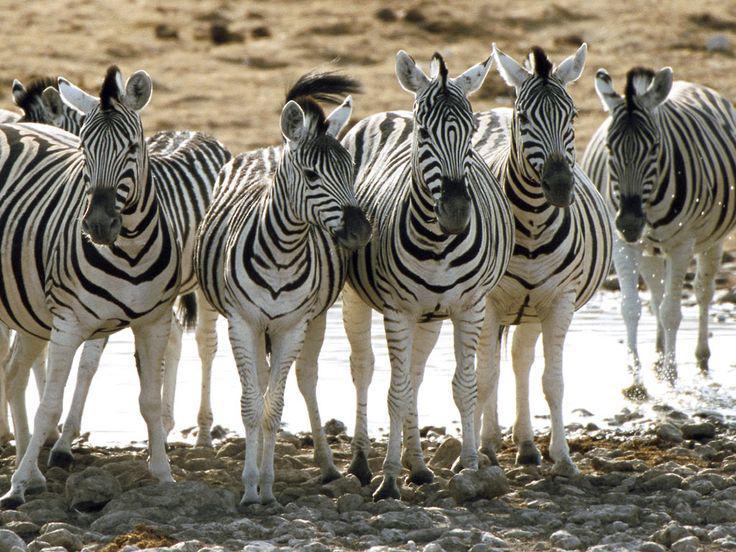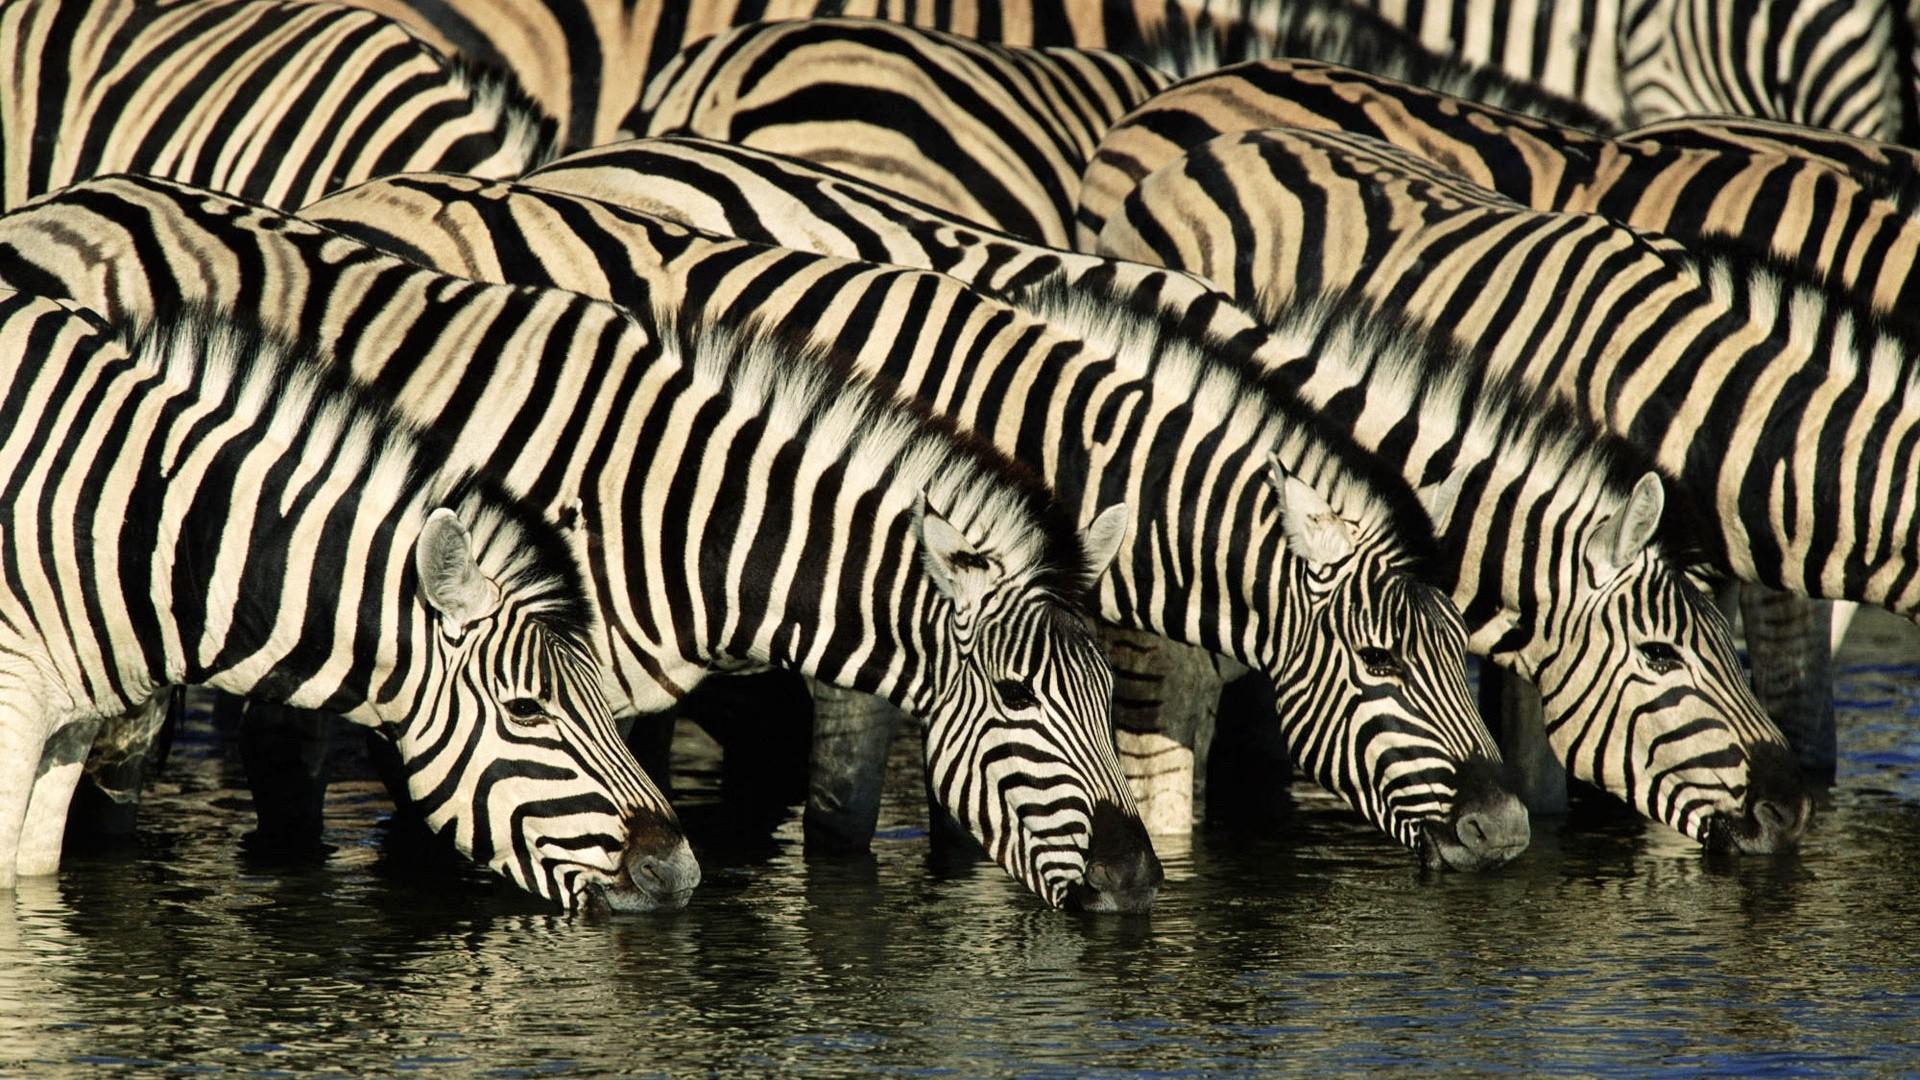The first image is the image on the left, the second image is the image on the right. Considering the images on both sides, is "Neither image in the pair shows fewer than three zebras." valid? Answer yes or no. Yes. The first image is the image on the left, the second image is the image on the right. For the images displayed, is the sentence "At least three zebras in each image are facing the same direction." factually correct? Answer yes or no. Yes. 